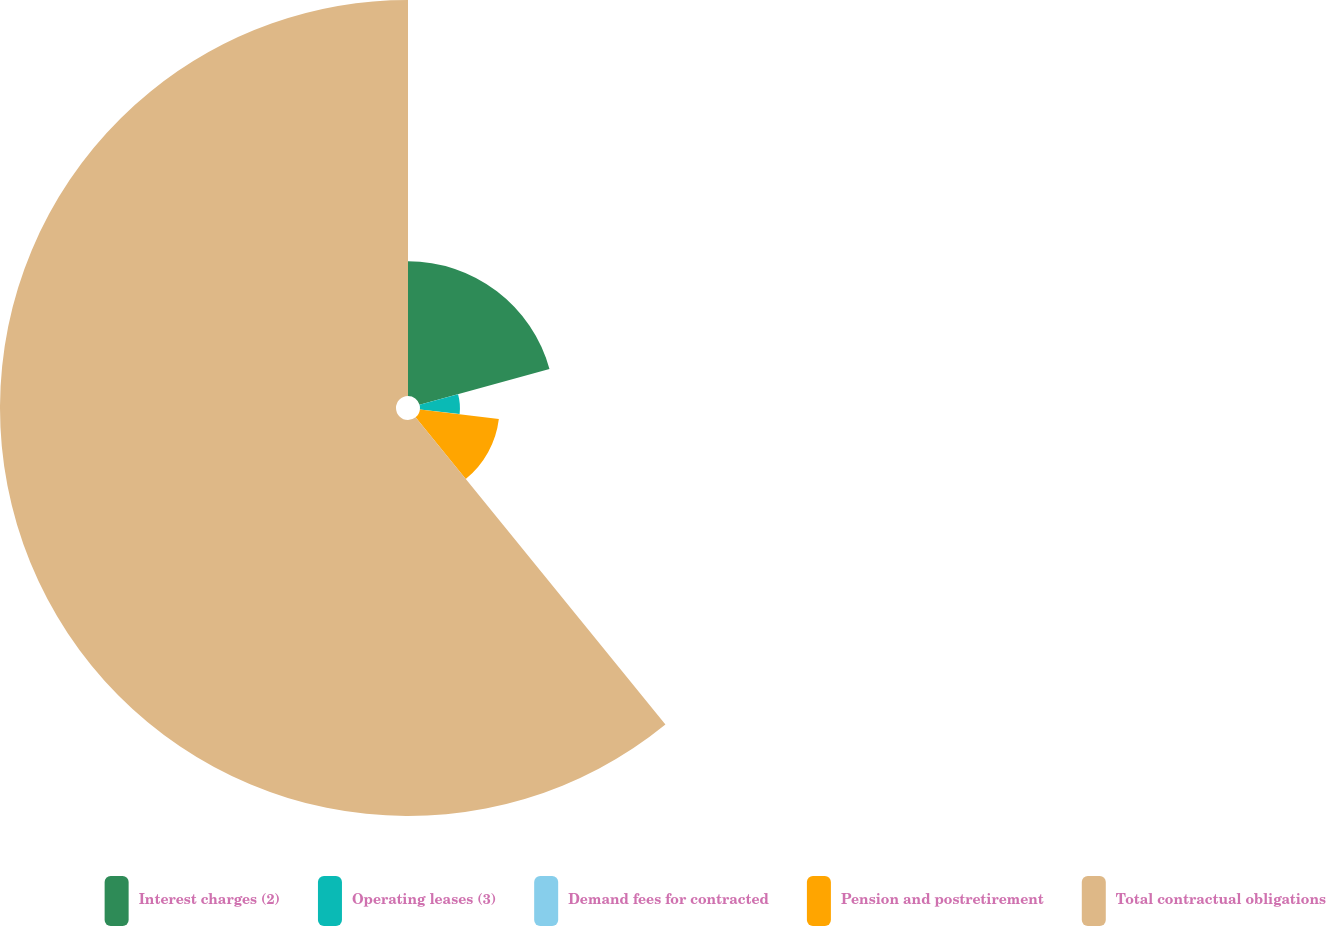Convert chart to OTSL. <chart><loc_0><loc_0><loc_500><loc_500><pie_chart><fcel>Interest charges (2)<fcel>Operating leases (3)<fcel>Demand fees for contracted<fcel>Pension and postretirement<fcel>Total contractual obligations<nl><fcel>20.71%<fcel>6.14%<fcel>0.06%<fcel>12.22%<fcel>60.86%<nl></chart> 